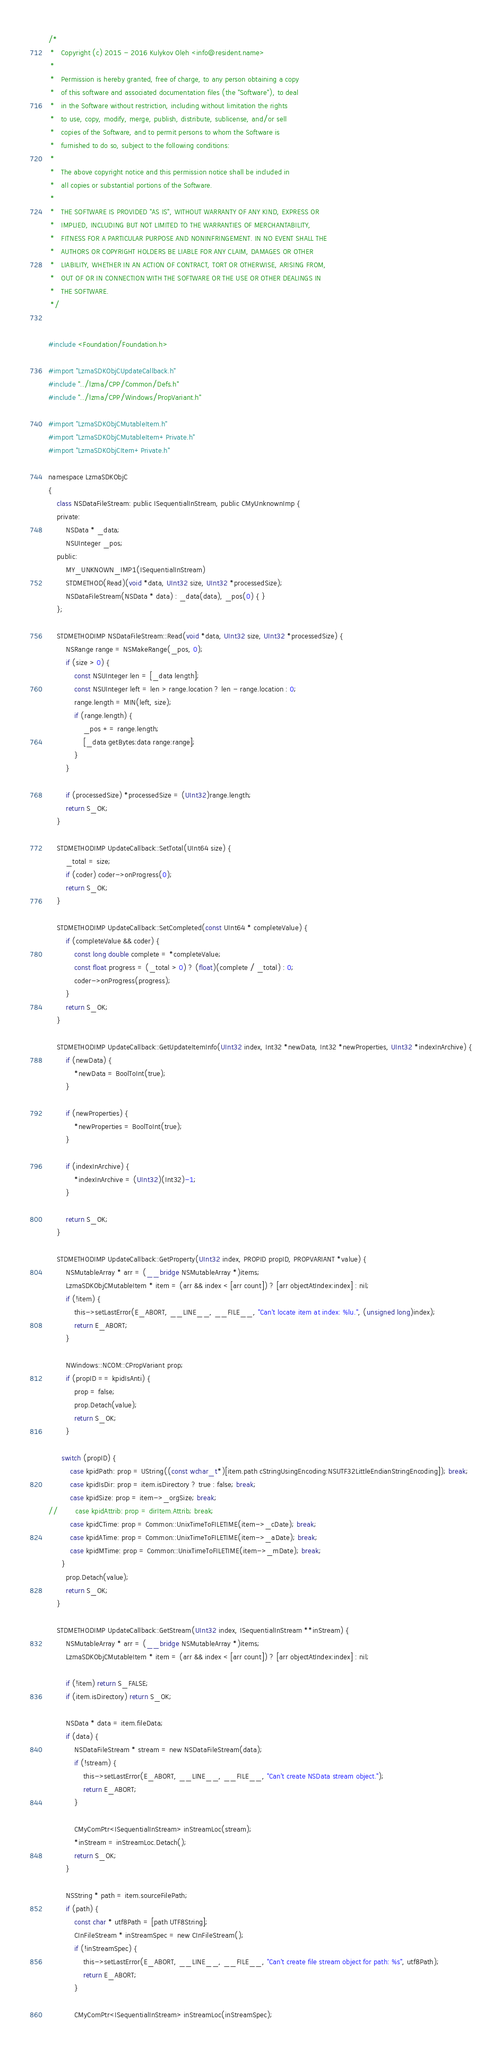<code> <loc_0><loc_0><loc_500><loc_500><_ObjectiveC_>/*
 *   Copyright (c) 2015 - 2016 Kulykov Oleh <info@resident.name>
 *
 *   Permission is hereby granted, free of charge, to any person obtaining a copy
 *   of this software and associated documentation files (the "Software"), to deal
 *   in the Software without restriction, including without limitation the rights
 *   to use, copy, modify, merge, publish, distribute, sublicense, and/or sell
 *   copies of the Software, and to permit persons to whom the Software is
 *   furnished to do so, subject to the following conditions:
 *
 *   The above copyright notice and this permission notice shall be included in
 *   all copies or substantial portions of the Software.
 *
 *   THE SOFTWARE IS PROVIDED "AS IS", WITHOUT WARRANTY OF ANY KIND, EXPRESS OR
 *   IMPLIED, INCLUDING BUT NOT LIMITED TO THE WARRANTIES OF MERCHANTABILITY,
 *   FITNESS FOR A PARTICULAR PURPOSE AND NONINFRINGEMENT. IN NO EVENT SHALL THE
 *   AUTHORS OR COPYRIGHT HOLDERS BE LIABLE FOR ANY CLAIM, DAMAGES OR OTHER
 *   LIABILITY, WHETHER IN AN ACTION OF CONTRACT, TORT OR OTHERWISE, ARISING FROM,
 *   OUT OF OR IN CONNECTION WITH THE SOFTWARE OR THE USE OR OTHER DEALINGS IN
 *   THE SOFTWARE.
 */


#include <Foundation/Foundation.h>

#import "LzmaSDKObjCUpdateCallback.h"
#include "../lzma/CPP/Common/Defs.h"
#include "../lzma/CPP/Windows/PropVariant.h"

#import "LzmaSDKObjCMutableItem.h"
#import "LzmaSDKObjCMutableItem+Private.h"
#import "LzmaSDKObjCItem+Private.h"

namespace LzmaSDKObjC
{
	class NSDataFileStream: public ISequentialInStream, public CMyUnknownImp {
	private:
		NSData * _data;
		NSUInteger _pos;
	public:
		MY_UNKNOWN_IMP1(ISequentialInStream)
		STDMETHOD(Read)(void *data, UInt32 size, UInt32 *processedSize);
		NSDataFileStream(NSData * data) : _data(data), _pos(0) { }
	};

	STDMETHODIMP NSDataFileStream::Read(void *data, UInt32 size, UInt32 *processedSize) {
		NSRange range = NSMakeRange(_pos, 0);
		if (size > 0) {
			const NSUInteger len = [_data length];
			const NSUInteger left = len > range.location ? len - range.location : 0;
			range.length = MIN(left, size);
			if (range.length) {
				_pos += range.length;
				[_data getBytes:data range:range];
			}
		}

		if (processedSize) *processedSize = (UInt32)range.length;
		return S_OK;
	}

	STDMETHODIMP UpdateCallback::SetTotal(UInt64 size) {
		_total = size;
		if (coder) coder->onProgress(0);
		return S_OK;
	}

	STDMETHODIMP UpdateCallback::SetCompleted(const UInt64 * completeValue) {
		if (completeValue && coder) {
			const long double complete = *completeValue;
			const float progress = (_total > 0) ? (float)(complete / _total) : 0;
			coder->onProgress(progress);
		}
		return S_OK;
	}

	STDMETHODIMP UpdateCallback::GetUpdateItemInfo(UInt32 index, Int32 *newData, Int32 *newProperties, UInt32 *indexInArchive) {
		if (newData) {
			*newData = BoolToInt(true);
		}

		if (newProperties) {
			*newProperties = BoolToInt(true);
		}

		if (indexInArchive) {
			*indexInArchive = (UInt32)(Int32)-1;
		}

		return S_OK;
	}

	STDMETHODIMP UpdateCallback::GetProperty(UInt32 index, PROPID propID, PROPVARIANT *value) {
		NSMutableArray * arr = (__bridge NSMutableArray *)items;
		LzmaSDKObjCMutableItem * item = (arr && index < [arr count]) ? [arr objectAtIndex:index] : nil;
		if (!item) {
			this->setLastError(E_ABORT, __LINE__, __FILE__, "Can't locate item at index: %lu.", (unsigned long)index);
			return E_ABORT;
		}

		NWindows::NCOM::CPropVariant prop;
		if (propID == kpidIsAnti) {
			prop = false;
			prop.Detach(value);
			return S_OK;
		}

	  switch (propID) {
		  case kpidPath: prop = UString((const wchar_t*)[item.path cStringUsingEncoding:NSUTF32LittleEndianStringEncoding]); break;
		  case kpidIsDir: prop = item.isDirectory ? true : false; break;
		  case kpidSize: prop = item->_orgSize; break;
//		  case kpidAttrib: prop = dirItem.Attrib; break;
		  case kpidCTime: prop = Common::UnixTimeToFILETIME(item->_cDate); break;
		  case kpidATime: prop = Common::UnixTimeToFILETIME(item->_aDate); break;
		  case kpidMTime: prop = Common::UnixTimeToFILETIME(item->_mDate); break;
	  }
		prop.Detach(value);
		return S_OK;
	}

	STDMETHODIMP UpdateCallback::GetStream(UInt32 index, ISequentialInStream **inStream) {
		NSMutableArray * arr = (__bridge NSMutableArray *)items;
		LzmaSDKObjCMutableItem * item = (arr && index < [arr count]) ? [arr objectAtIndex:index] : nil;

		if (!item) return S_FALSE;
		if (item.isDirectory) return S_OK;

		NSData * data = item.fileData;
		if (data) {
			NSDataFileStream * stream = new NSDataFileStream(data);
			if (!stream) {
				this->setLastError(E_ABORT, __LINE__, __FILE__, "Can't create NSData stream object.");
				return E_ABORT;
			}

			CMyComPtr<ISequentialInStream> inStreamLoc(stream);
			*inStream = inStreamLoc.Detach();
			return S_OK;
		}

		NSString * path = item.sourceFilePath;
		if (path) {
			const char * utf8Path = [path UTF8String];
			CInFileStream * inStreamSpec = new CInFileStream();
			if (!inStreamSpec) {
				this->setLastError(E_ABORT, __LINE__, __FILE__, "Can't create file stream object for path: %s", utf8Path);
				return E_ABORT;
			}

			CMyComPtr<ISequentialInStream> inStreamLoc(inStreamSpec);</code> 